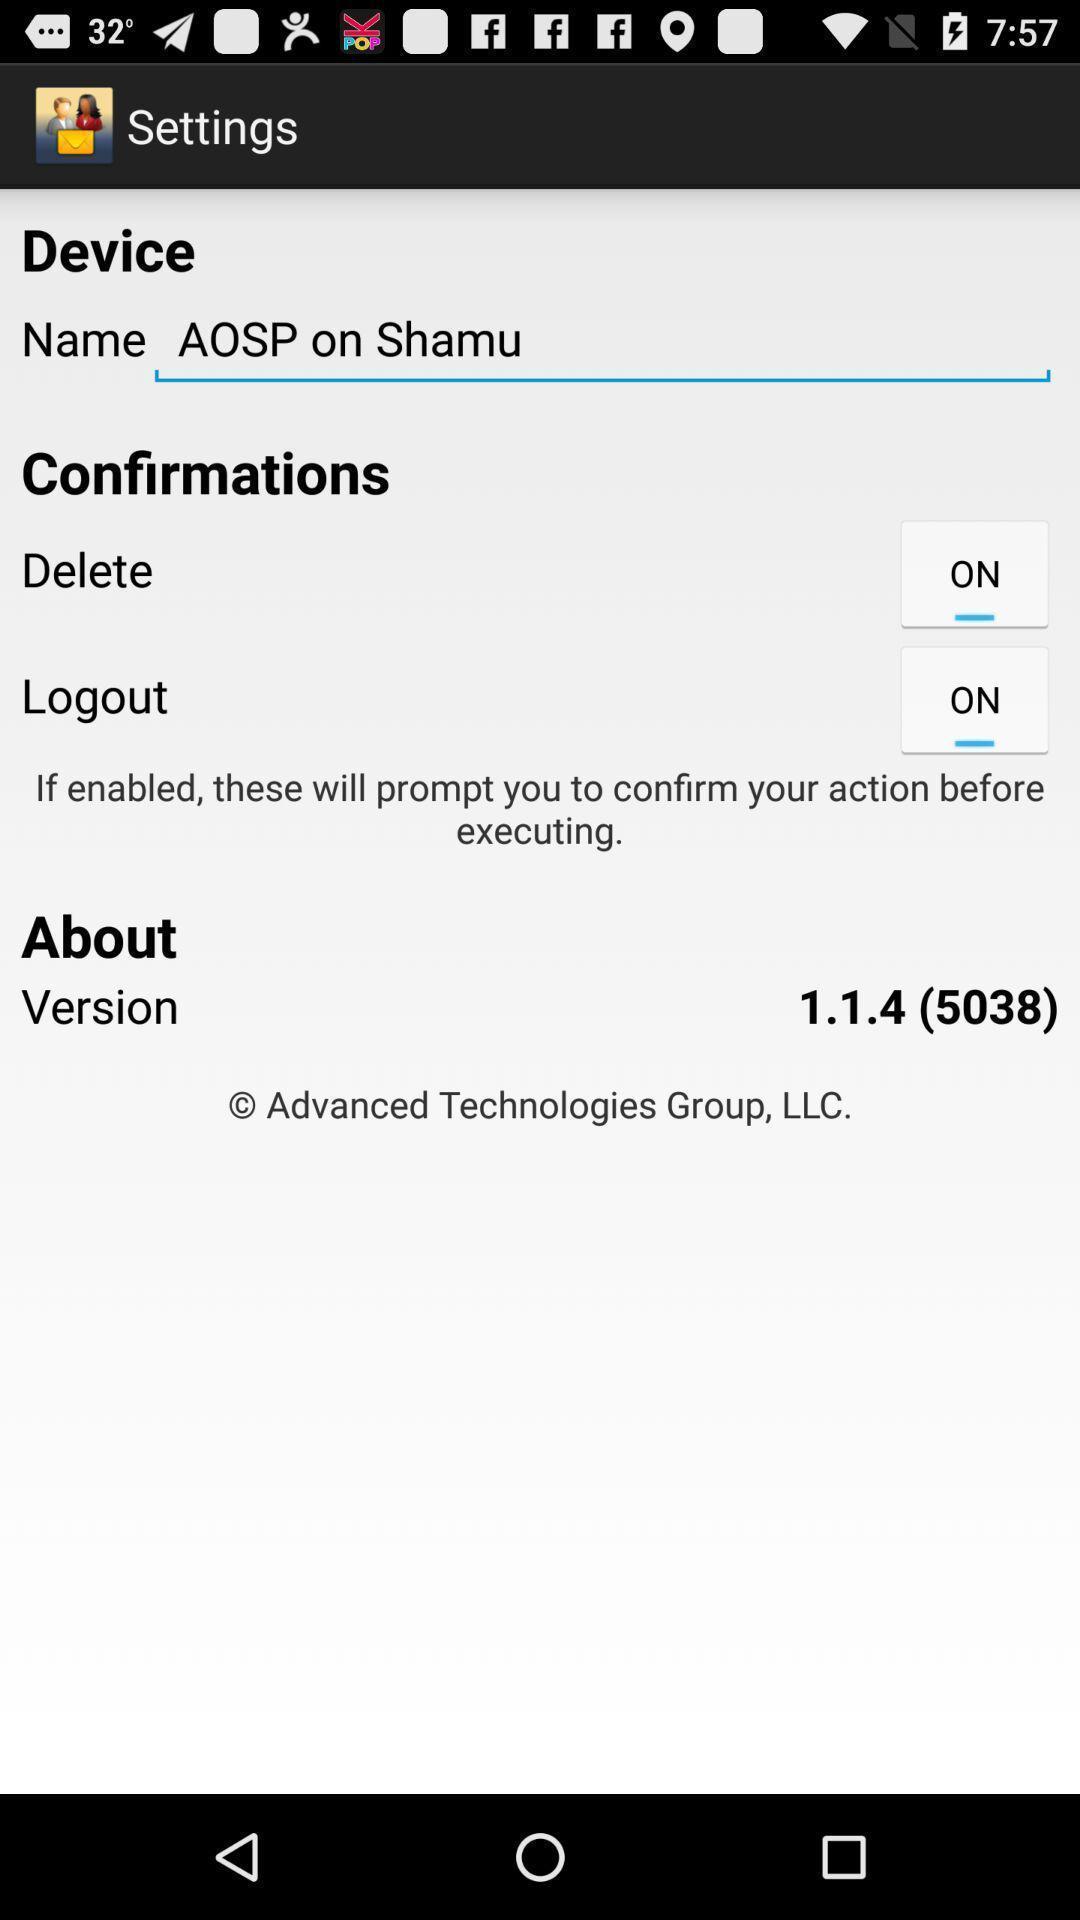Summarize the information in this screenshot. Settings page. 